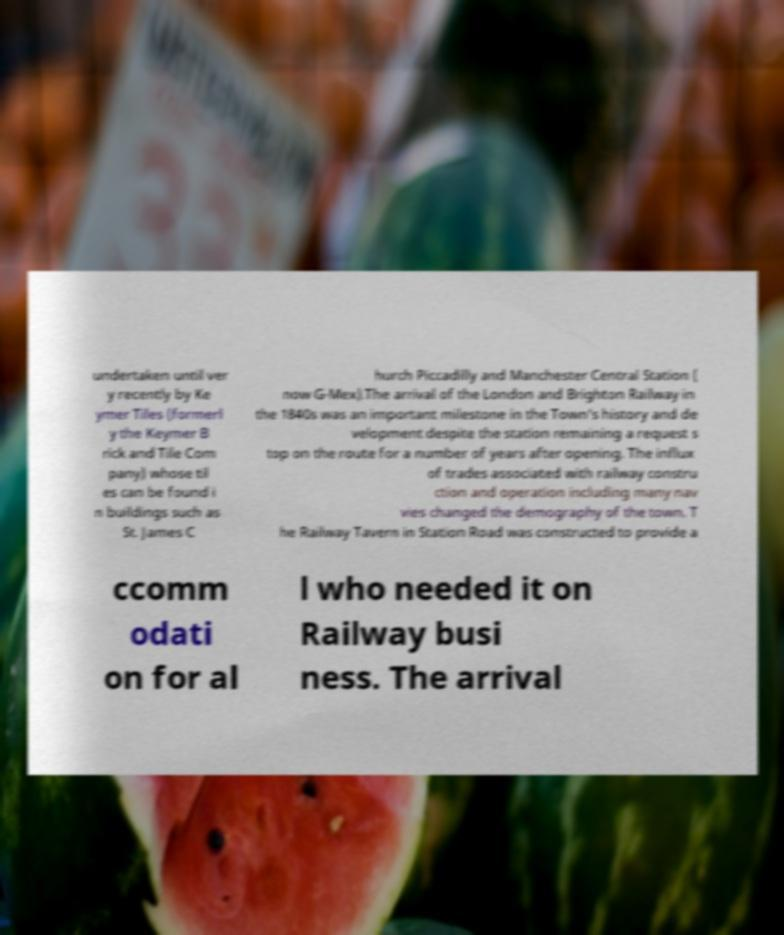For documentation purposes, I need the text within this image transcribed. Could you provide that? undertaken until ver y recently by Ke ymer Tiles (formerl y the Keymer B rick and Tile Com pany) whose til es can be found i n buildings such as St. James C hurch Piccadilly and Manchester Central Station ( now G-Mex).The arrival of the London and Brighton Railway in the 1840s was an important milestone in the Town's history and de velopment despite the station remaining a request s top on the route for a number of years after opening. The influx of trades associated with railway constru ction and operation including many nav vies changed the demography of the town. T he Railway Tavern in Station Road was constructed to provide a ccomm odati on for al l who needed it on Railway busi ness. The arrival 